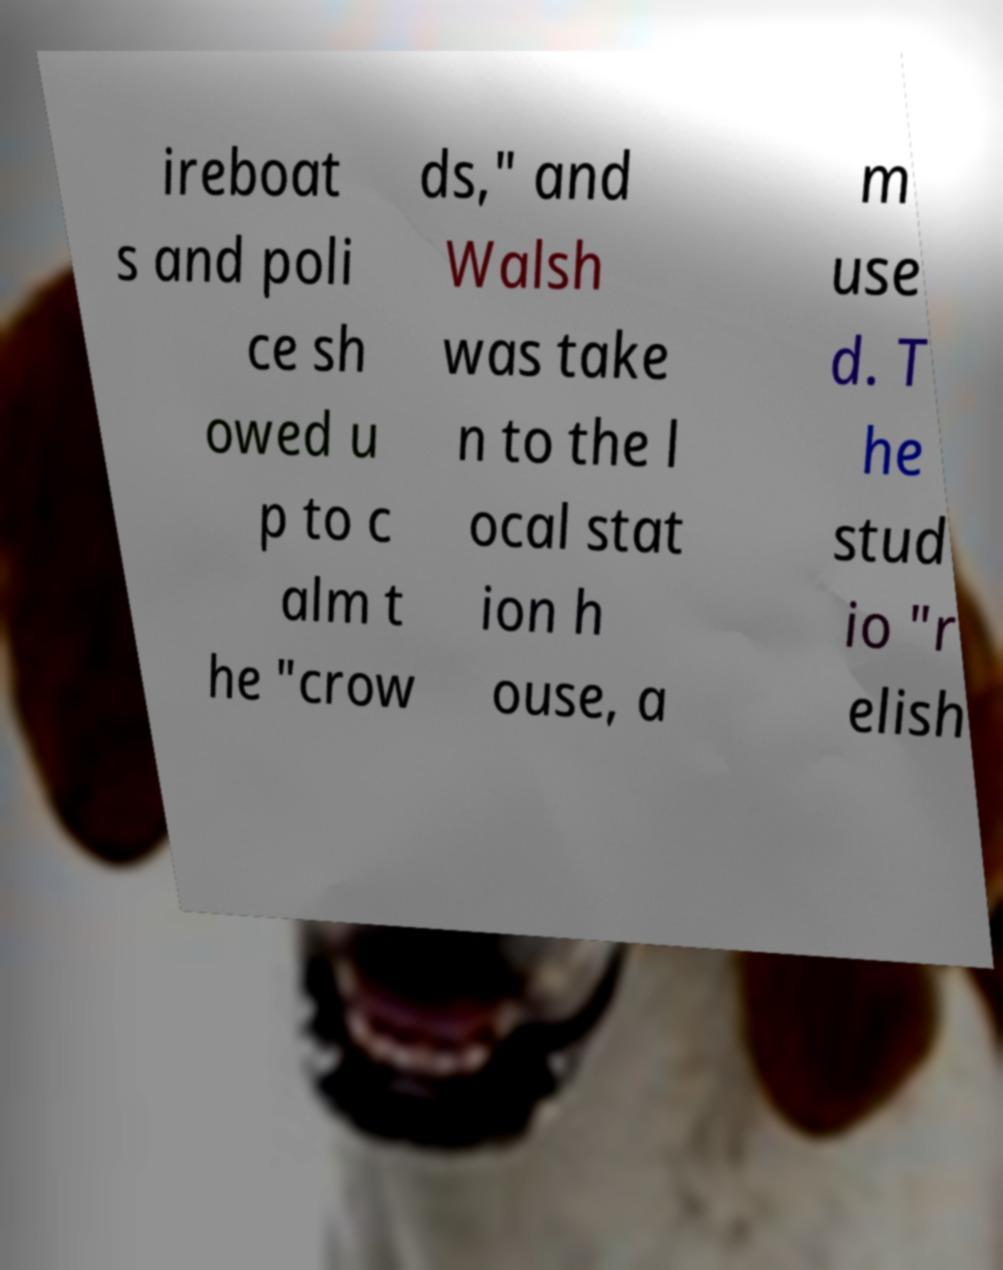Could you assist in decoding the text presented in this image and type it out clearly? ireboat s and poli ce sh owed u p to c alm t he "crow ds," and Walsh was take n to the l ocal stat ion h ouse, a m use d. T he stud io "r elish 